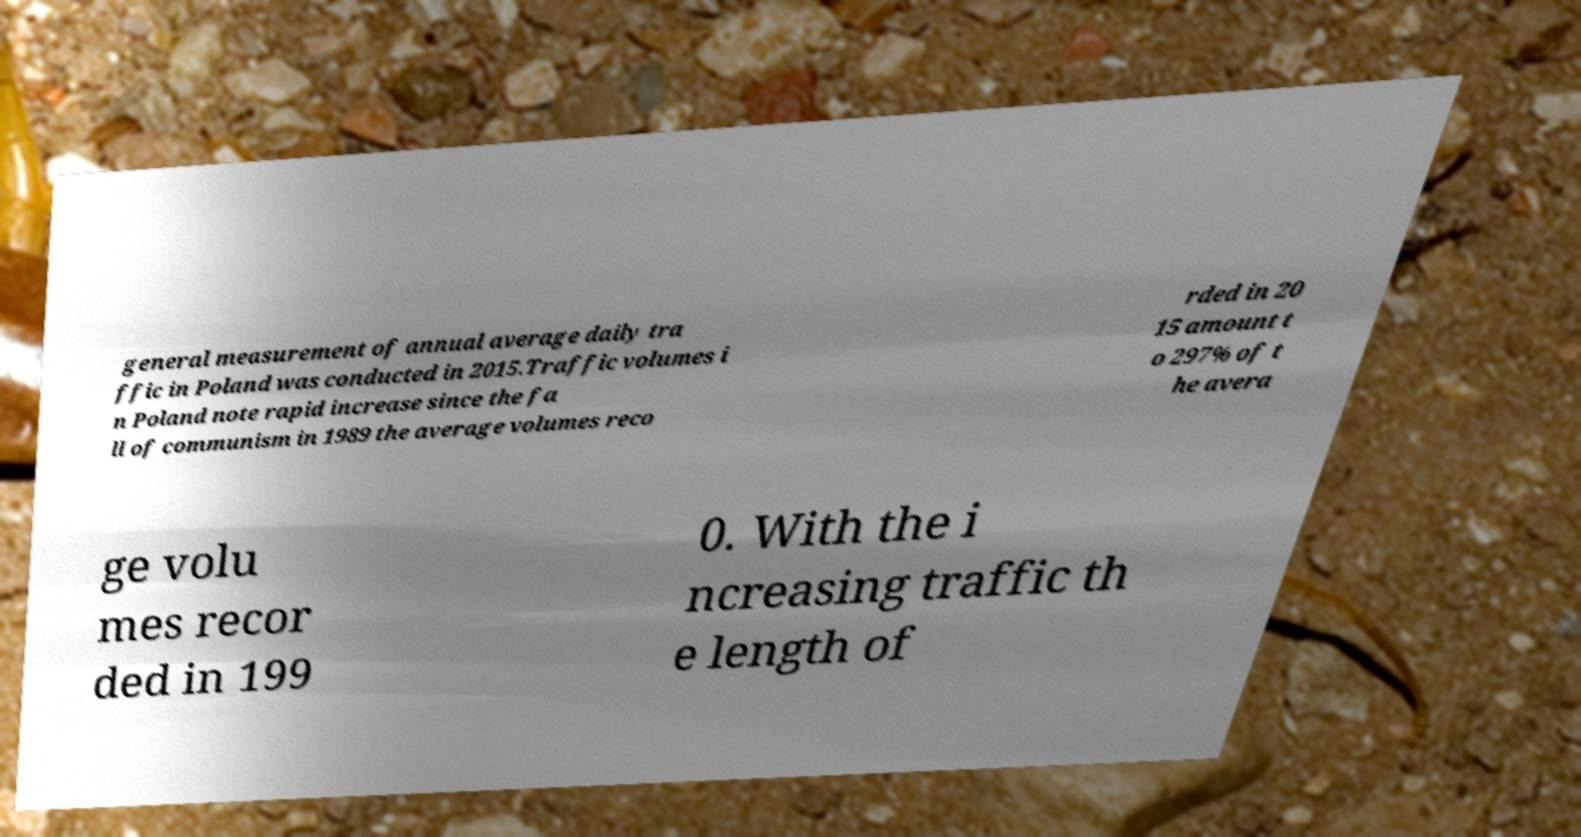There's text embedded in this image that I need extracted. Can you transcribe it verbatim? general measurement of annual average daily tra ffic in Poland was conducted in 2015.Traffic volumes i n Poland note rapid increase since the fa ll of communism in 1989 the average volumes reco rded in 20 15 amount t o 297% of t he avera ge volu mes recor ded in 199 0. With the i ncreasing traffic th e length of 